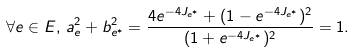<formula> <loc_0><loc_0><loc_500><loc_500>\forall e \in E , \, a _ { e } ^ { 2 } + b _ { e ^ { * } } ^ { 2 } = \frac { 4 e ^ { - 4 J _ { e ^ { * } } } + ( 1 - e ^ { - 4 J _ { e ^ { * } } } ) ^ { 2 } } { ( 1 + e ^ { - 4 J _ { e ^ { * } } } ) ^ { 2 } } = 1 .</formula> 